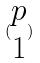<formula> <loc_0><loc_0><loc_500><loc_500>( \begin{matrix} p \\ 1 \end{matrix} )</formula> 